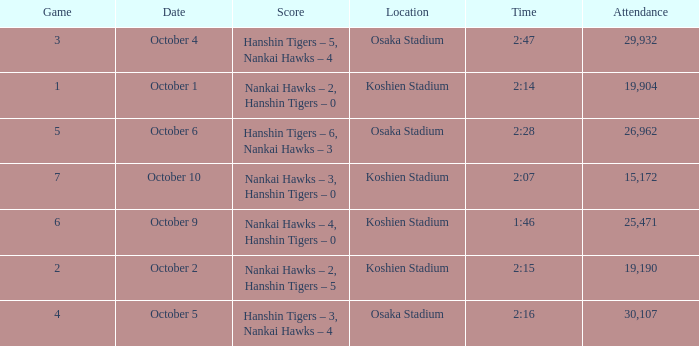How many games had a Time of 2:14? 1.0. 